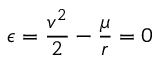Convert formula to latex. <formula><loc_0><loc_0><loc_500><loc_500>\epsilon = { \frac { v ^ { 2 } } { 2 } } - { \frac { \mu } { r } } = 0</formula> 